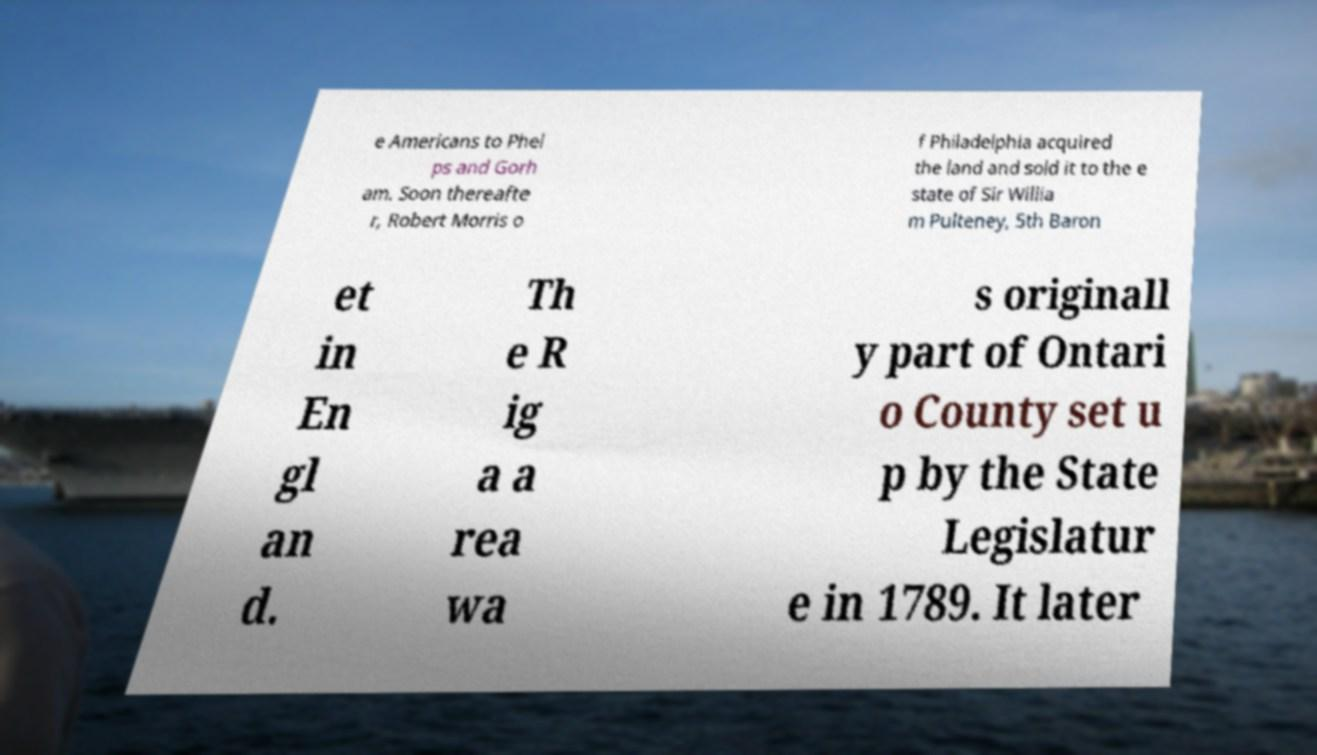What messages or text are displayed in this image? I need them in a readable, typed format. e Americans to Phel ps and Gorh am. Soon thereafte r, Robert Morris o f Philadelphia acquired the land and sold it to the e state of Sir Willia m Pulteney, 5th Baron et in En gl an d. Th e R ig a a rea wa s originall y part of Ontari o County set u p by the State Legislatur e in 1789. It later 